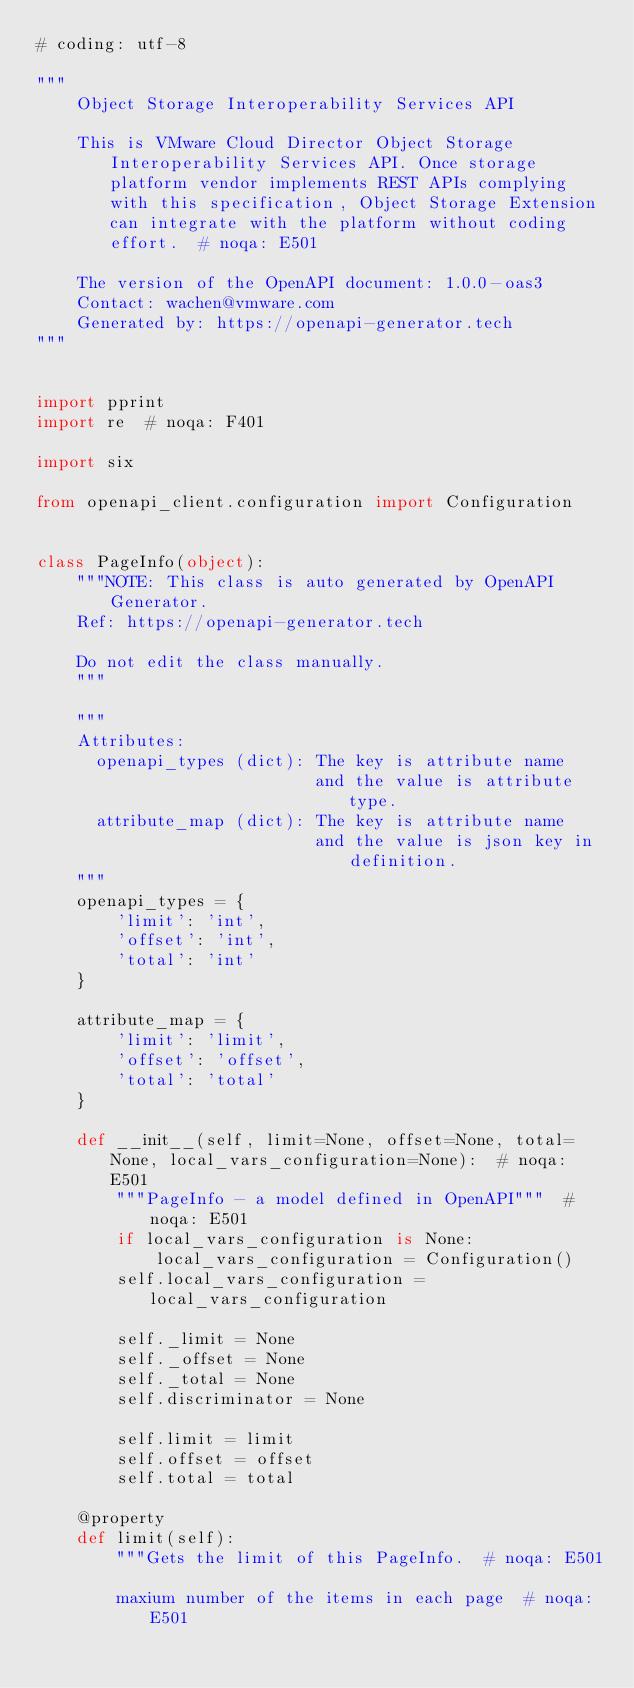<code> <loc_0><loc_0><loc_500><loc_500><_Python_># coding: utf-8

"""
    Object Storage Interoperability Services API

    This is VMware Cloud Director Object Storage Interoperability Services API. Once storage platform vendor implements REST APIs complying with this specification, Object Storage Extension can integrate with the platform without coding effort.  # noqa: E501

    The version of the OpenAPI document: 1.0.0-oas3
    Contact: wachen@vmware.com
    Generated by: https://openapi-generator.tech
"""


import pprint
import re  # noqa: F401

import six

from openapi_client.configuration import Configuration


class PageInfo(object):
    """NOTE: This class is auto generated by OpenAPI Generator.
    Ref: https://openapi-generator.tech

    Do not edit the class manually.
    """

    """
    Attributes:
      openapi_types (dict): The key is attribute name
                            and the value is attribute type.
      attribute_map (dict): The key is attribute name
                            and the value is json key in definition.
    """
    openapi_types = {
        'limit': 'int',
        'offset': 'int',
        'total': 'int'
    }

    attribute_map = {
        'limit': 'limit',
        'offset': 'offset',
        'total': 'total'
    }

    def __init__(self, limit=None, offset=None, total=None, local_vars_configuration=None):  # noqa: E501
        """PageInfo - a model defined in OpenAPI"""  # noqa: E501
        if local_vars_configuration is None:
            local_vars_configuration = Configuration()
        self.local_vars_configuration = local_vars_configuration

        self._limit = None
        self._offset = None
        self._total = None
        self.discriminator = None

        self.limit = limit
        self.offset = offset
        self.total = total

    @property
    def limit(self):
        """Gets the limit of this PageInfo.  # noqa: E501

        maxium number of the items in each page  # noqa: E501
</code> 